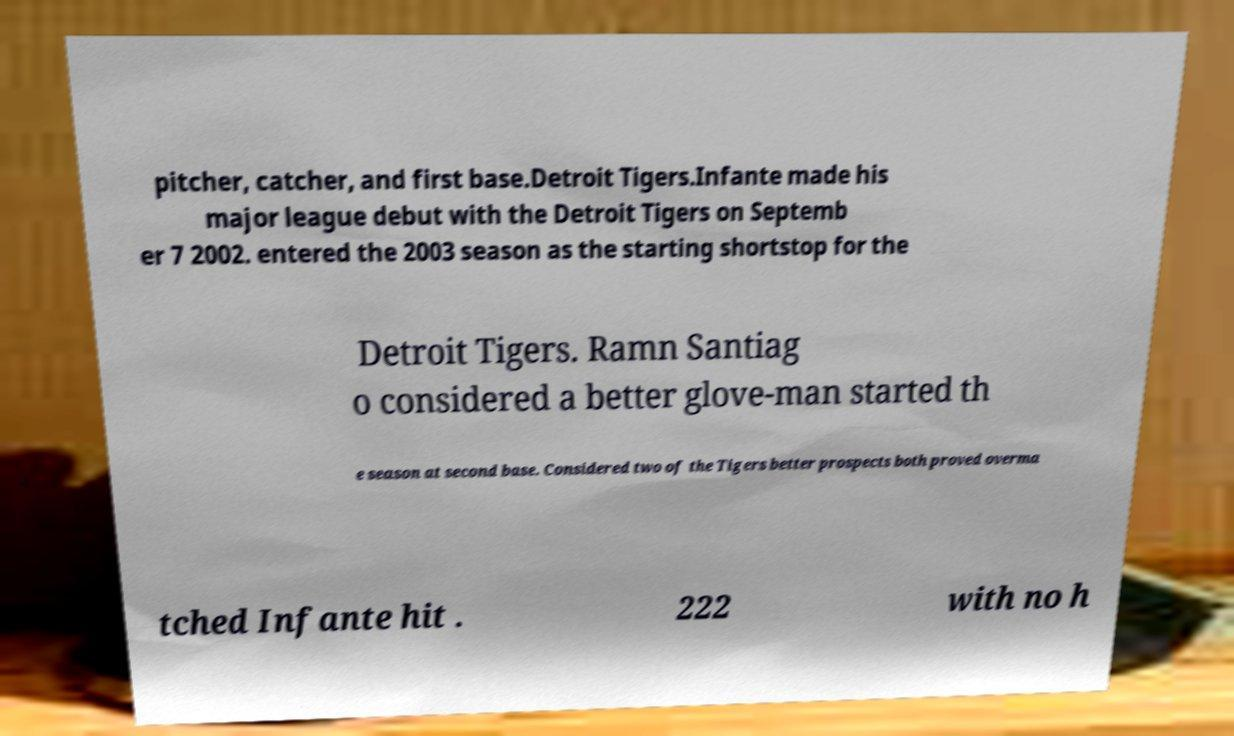Could you assist in decoding the text presented in this image and type it out clearly? pitcher, catcher, and first base.Detroit Tigers.Infante made his major league debut with the Detroit Tigers on Septemb er 7 2002. entered the 2003 season as the starting shortstop for the Detroit Tigers. Ramn Santiag o considered a better glove-man started th e season at second base. Considered two of the Tigers better prospects both proved overma tched Infante hit . 222 with no h 